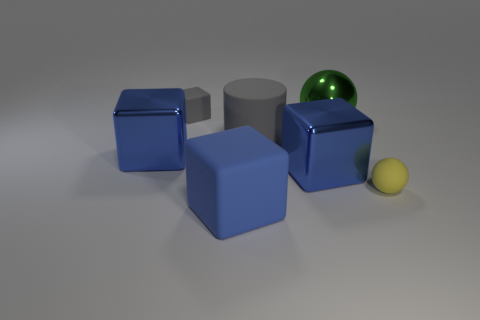How many big matte objects have the same color as the tiny cube?
Provide a succinct answer. 1. There is a big blue metallic thing to the right of the tiny matte block; does it have the same shape as the tiny rubber object in front of the tiny gray thing?
Offer a terse response. No. The big block in front of the big blue metallic thing that is on the right side of the large matte object that is in front of the tiny rubber ball is what color?
Offer a terse response. Blue. The tiny thing to the right of the big green thing is what color?
Keep it short and to the point. Yellow. There is a matte cube that is the same size as the green metal sphere; what color is it?
Ensure brevity in your answer.  Blue. Does the yellow thing have the same size as the gray block?
Give a very brief answer. Yes. What number of blue objects are in front of the yellow rubber sphere?
Your answer should be compact. 1. What number of objects are either tiny blocks that are on the left side of the big green shiny sphere or tiny blue matte cubes?
Offer a terse response. 1. Is the number of objects behind the gray block greater than the number of big cylinders that are behind the large green thing?
Provide a succinct answer. No. What size is the matte object that is the same color as the tiny block?
Keep it short and to the point. Large. 